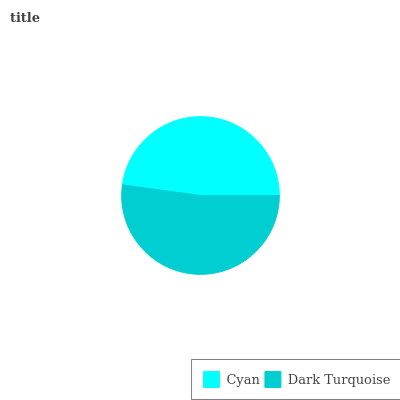Is Cyan the minimum?
Answer yes or no. Yes. Is Dark Turquoise the maximum?
Answer yes or no. Yes. Is Dark Turquoise the minimum?
Answer yes or no. No. Is Dark Turquoise greater than Cyan?
Answer yes or no. Yes. Is Cyan less than Dark Turquoise?
Answer yes or no. Yes. Is Cyan greater than Dark Turquoise?
Answer yes or no. No. Is Dark Turquoise less than Cyan?
Answer yes or no. No. Is Dark Turquoise the high median?
Answer yes or no. Yes. Is Cyan the low median?
Answer yes or no. Yes. Is Cyan the high median?
Answer yes or no. No. Is Dark Turquoise the low median?
Answer yes or no. No. 